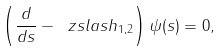Convert formula to latex. <formula><loc_0><loc_0><loc_500><loc_500>\left ( \frac { d } { d s } - \ z s l a s h _ { 1 , 2 } \right ) \psi ( s ) = 0 ,</formula> 